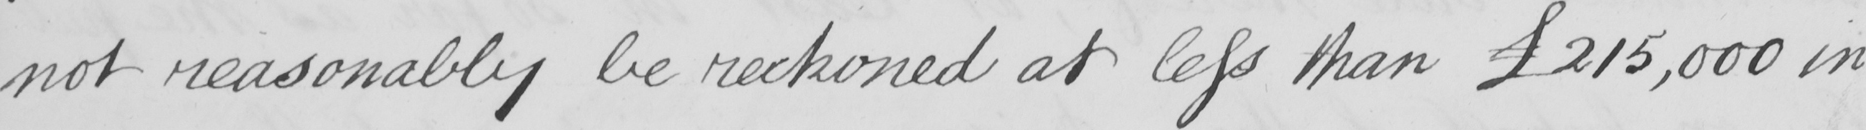Can you read and transcribe this handwriting? not reasonably be reckoned at less than  £215,000 in 